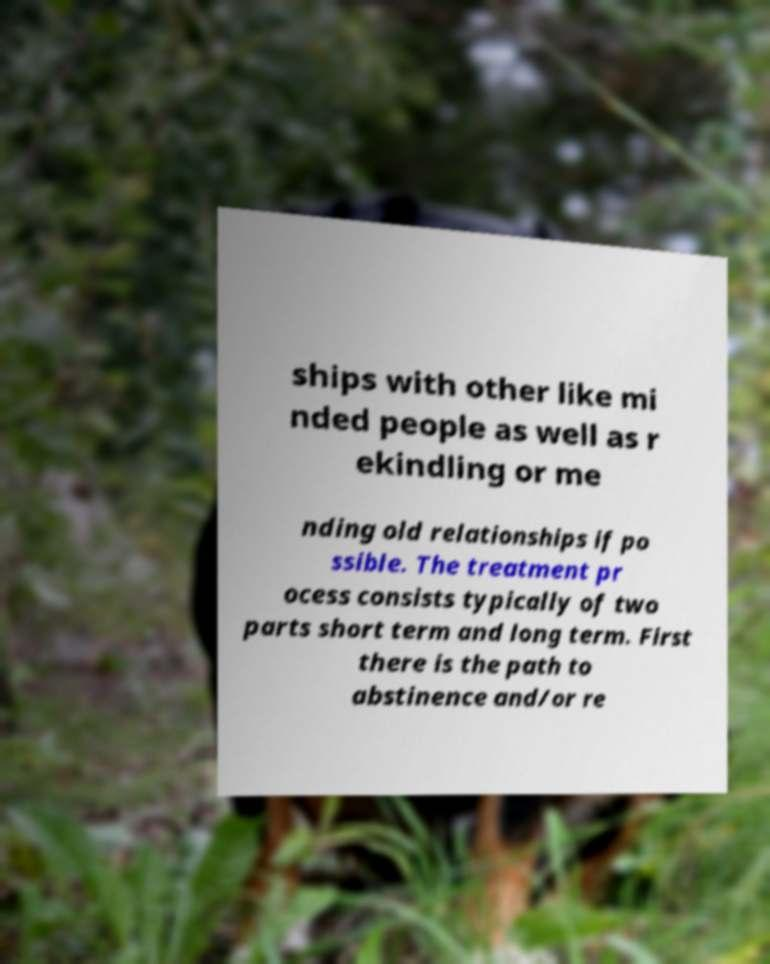Can you accurately transcribe the text from the provided image for me? ships with other like mi nded people as well as r ekindling or me nding old relationships if po ssible. The treatment pr ocess consists typically of two parts short term and long term. First there is the path to abstinence and/or re 